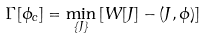Convert formula to latex. <formula><loc_0><loc_0><loc_500><loc_500>\Gamma [ \phi _ { c } ] = \min _ { \{ J \} } \left [ W [ J ] - ( J , \phi ) \right ]</formula> 